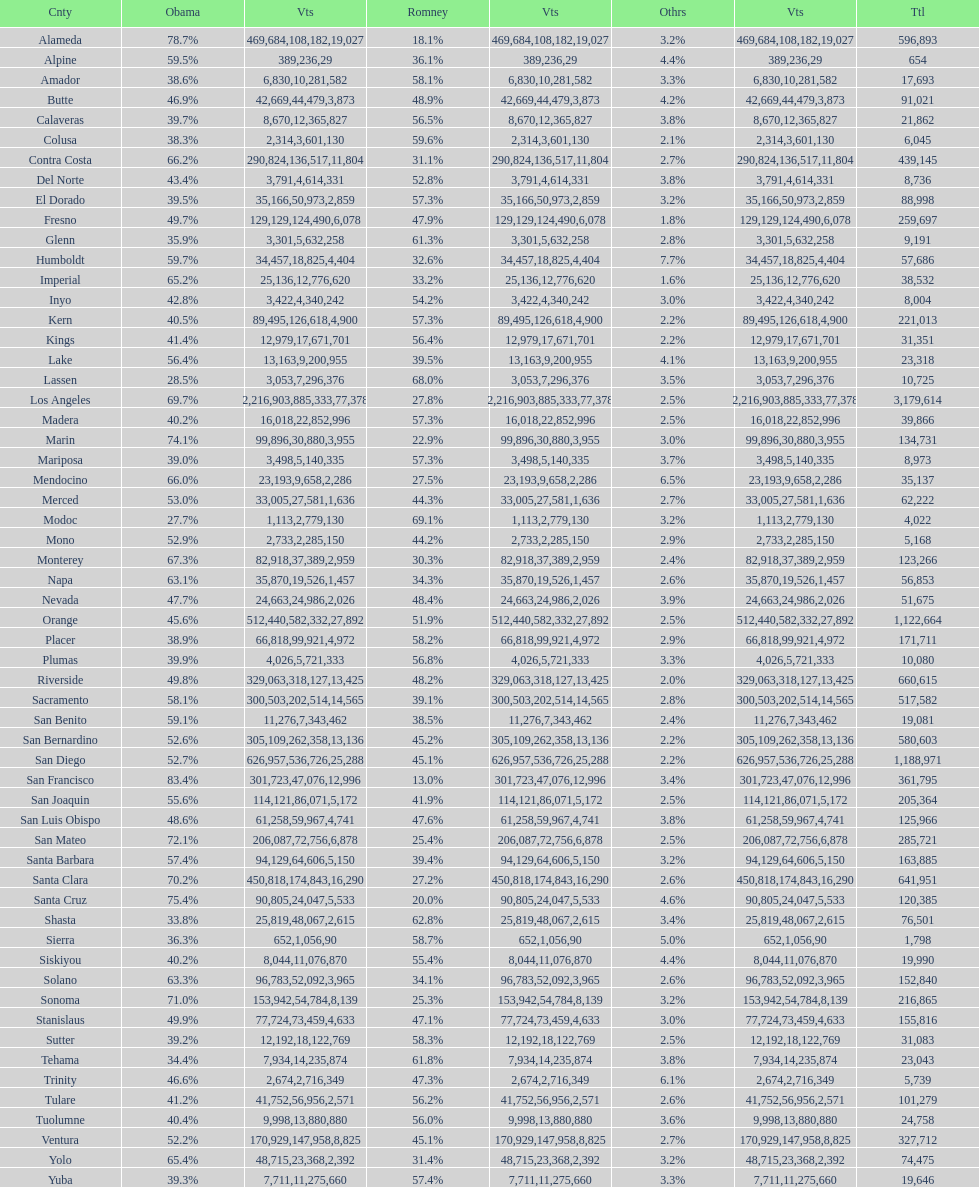Can you parse all the data within this table? {'header': ['Cnty', 'Obama', 'Vts', 'Romney', 'Vts', 'Othrs', 'Vts', 'Ttl'], 'rows': [['Alameda', '78.7%', '469,684', '18.1%', '108,182', '3.2%', '19,027', '596,893'], ['Alpine', '59.5%', '389', '36.1%', '236', '4.4%', '29', '654'], ['Amador', '38.6%', '6,830', '58.1%', '10,281', '3.3%', '582', '17,693'], ['Butte', '46.9%', '42,669', '48.9%', '44,479', '4.2%', '3,873', '91,021'], ['Calaveras', '39.7%', '8,670', '56.5%', '12,365', '3.8%', '827', '21,862'], ['Colusa', '38.3%', '2,314', '59.6%', '3,601', '2.1%', '130', '6,045'], ['Contra Costa', '66.2%', '290,824', '31.1%', '136,517', '2.7%', '11,804', '439,145'], ['Del Norte', '43.4%', '3,791', '52.8%', '4,614', '3.8%', '331', '8,736'], ['El Dorado', '39.5%', '35,166', '57.3%', '50,973', '3.2%', '2,859', '88,998'], ['Fresno', '49.7%', '129,129', '47.9%', '124,490', '1.8%', '6,078', '259,697'], ['Glenn', '35.9%', '3,301', '61.3%', '5,632', '2.8%', '258', '9,191'], ['Humboldt', '59.7%', '34,457', '32.6%', '18,825', '7.7%', '4,404', '57,686'], ['Imperial', '65.2%', '25,136', '33.2%', '12,776', '1.6%', '620', '38,532'], ['Inyo', '42.8%', '3,422', '54.2%', '4,340', '3.0%', '242', '8,004'], ['Kern', '40.5%', '89,495', '57.3%', '126,618', '2.2%', '4,900', '221,013'], ['Kings', '41.4%', '12,979', '56.4%', '17,671', '2.2%', '701', '31,351'], ['Lake', '56.4%', '13,163', '39.5%', '9,200', '4.1%', '955', '23,318'], ['Lassen', '28.5%', '3,053', '68.0%', '7,296', '3.5%', '376', '10,725'], ['Los Angeles', '69.7%', '2,216,903', '27.8%', '885,333', '2.5%', '77,378', '3,179,614'], ['Madera', '40.2%', '16,018', '57.3%', '22,852', '2.5%', '996', '39,866'], ['Marin', '74.1%', '99,896', '22.9%', '30,880', '3.0%', '3,955', '134,731'], ['Mariposa', '39.0%', '3,498', '57.3%', '5,140', '3.7%', '335', '8,973'], ['Mendocino', '66.0%', '23,193', '27.5%', '9,658', '6.5%', '2,286', '35,137'], ['Merced', '53.0%', '33,005', '44.3%', '27,581', '2.7%', '1,636', '62,222'], ['Modoc', '27.7%', '1,113', '69.1%', '2,779', '3.2%', '130', '4,022'], ['Mono', '52.9%', '2,733', '44.2%', '2,285', '2.9%', '150', '5,168'], ['Monterey', '67.3%', '82,918', '30.3%', '37,389', '2.4%', '2,959', '123,266'], ['Napa', '63.1%', '35,870', '34.3%', '19,526', '2.6%', '1,457', '56,853'], ['Nevada', '47.7%', '24,663', '48.4%', '24,986', '3.9%', '2,026', '51,675'], ['Orange', '45.6%', '512,440', '51.9%', '582,332', '2.5%', '27,892', '1,122,664'], ['Placer', '38.9%', '66,818', '58.2%', '99,921', '2.9%', '4,972', '171,711'], ['Plumas', '39.9%', '4,026', '56.8%', '5,721', '3.3%', '333', '10,080'], ['Riverside', '49.8%', '329,063', '48.2%', '318,127', '2.0%', '13,425', '660,615'], ['Sacramento', '58.1%', '300,503', '39.1%', '202,514', '2.8%', '14,565', '517,582'], ['San Benito', '59.1%', '11,276', '38.5%', '7,343', '2.4%', '462', '19,081'], ['San Bernardino', '52.6%', '305,109', '45.2%', '262,358', '2.2%', '13,136', '580,603'], ['San Diego', '52.7%', '626,957', '45.1%', '536,726', '2.2%', '25,288', '1,188,971'], ['San Francisco', '83.4%', '301,723', '13.0%', '47,076', '3.4%', '12,996', '361,795'], ['San Joaquin', '55.6%', '114,121', '41.9%', '86,071', '2.5%', '5,172', '205,364'], ['San Luis Obispo', '48.6%', '61,258', '47.6%', '59,967', '3.8%', '4,741', '125,966'], ['San Mateo', '72.1%', '206,087', '25.4%', '72,756', '2.5%', '6,878', '285,721'], ['Santa Barbara', '57.4%', '94,129', '39.4%', '64,606', '3.2%', '5,150', '163,885'], ['Santa Clara', '70.2%', '450,818', '27.2%', '174,843', '2.6%', '16,290', '641,951'], ['Santa Cruz', '75.4%', '90,805', '20.0%', '24,047', '4.6%', '5,533', '120,385'], ['Shasta', '33.8%', '25,819', '62.8%', '48,067', '3.4%', '2,615', '76,501'], ['Sierra', '36.3%', '652', '58.7%', '1,056', '5.0%', '90', '1,798'], ['Siskiyou', '40.2%', '8,044', '55.4%', '11,076', '4.4%', '870', '19,990'], ['Solano', '63.3%', '96,783', '34.1%', '52,092', '2.6%', '3,965', '152,840'], ['Sonoma', '71.0%', '153,942', '25.3%', '54,784', '3.2%', '8,139', '216,865'], ['Stanislaus', '49.9%', '77,724', '47.1%', '73,459', '3.0%', '4,633', '155,816'], ['Sutter', '39.2%', '12,192', '58.3%', '18,122', '2.5%', '769', '31,083'], ['Tehama', '34.4%', '7,934', '61.8%', '14,235', '3.8%', '874', '23,043'], ['Trinity', '46.6%', '2,674', '47.3%', '2,716', '6.1%', '349', '5,739'], ['Tulare', '41.2%', '41,752', '56.2%', '56,956', '2.6%', '2,571', '101,279'], ['Tuolumne', '40.4%', '9,998', '56.0%', '13,880', '3.6%', '880', '24,758'], ['Ventura', '52.2%', '170,929', '45.1%', '147,958', '2.7%', '8,825', '327,712'], ['Yolo', '65.4%', '48,715', '31.4%', '23,368', '3.2%', '2,392', '74,475'], ['Yuba', '39.3%', '7,711', '57.4%', '11,275', '3.3%', '660', '19,646']]} Which county had the most total votes? Los Angeles. 